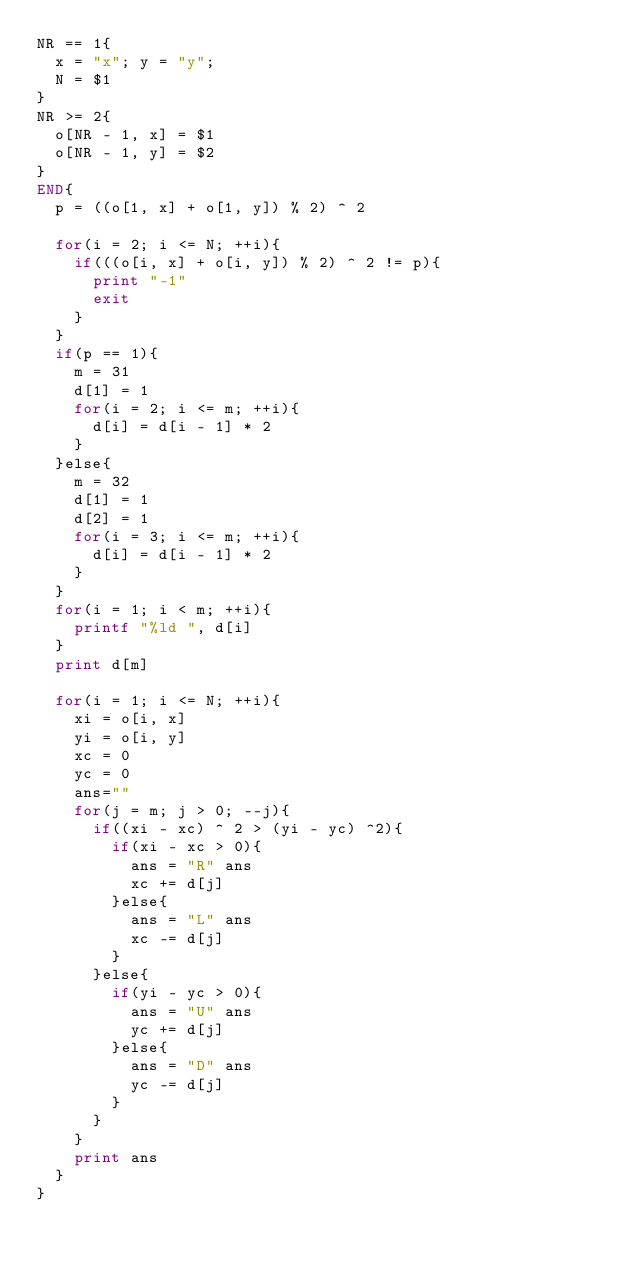Convert code to text. <code><loc_0><loc_0><loc_500><loc_500><_Awk_>NR == 1{
  x = "x"; y = "y";
  N = $1
}
NR >= 2{
  o[NR - 1, x] = $1
  o[NR - 1, y] = $2
}
END{
  p = ((o[1, x] + o[1, y]) % 2) ^ 2

  for(i = 2; i <= N; ++i){
    if(((o[i, x] + o[i, y]) % 2) ^ 2 != p){
      print "-1"
      exit
    }
  }
  if(p == 1){
    m = 31
    d[1] = 1
    for(i = 2; i <= m; ++i){
      d[i] = d[i - 1] * 2
    }
  }else{
    m = 32
    d[1] = 1
    d[2] = 1
    for(i = 3; i <= m; ++i){
      d[i] = d[i - 1] * 2
    }
  }
  for(i = 1; i < m; ++i){
    printf "%ld ", d[i]
  }
  print d[m]

  for(i = 1; i <= N; ++i){
    xi = o[i, x]
    yi = o[i, y]
    xc = 0
    yc = 0
    ans=""
    for(j = m; j > 0; --j){
      if((xi - xc) ^ 2 > (yi - yc) ^2){
        if(xi - xc > 0){
          ans = "R" ans
          xc += d[j]
        }else{
          ans = "L" ans
          xc -= d[j]
        }
      }else{
        if(yi - yc > 0){
          ans = "U" ans
          yc += d[j]
        }else{
          ans = "D" ans
          yc -= d[j]
        }
      }
    }
    print ans
  }
}</code> 